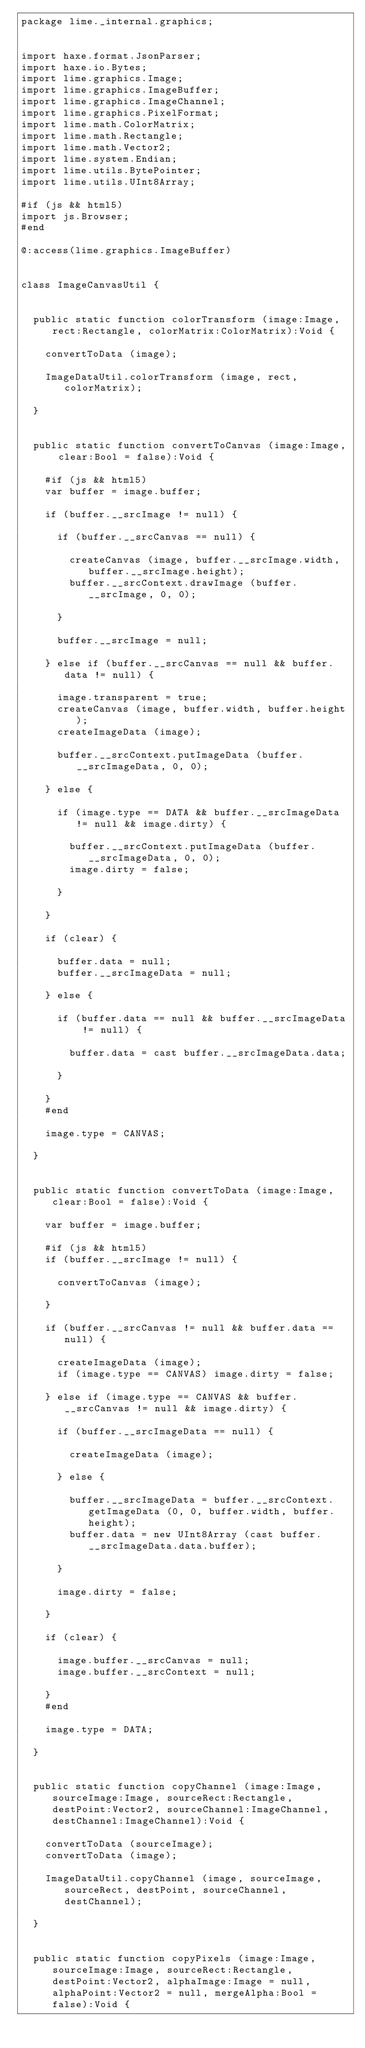Convert code to text. <code><loc_0><loc_0><loc_500><loc_500><_Haxe_>package lime._internal.graphics;


import haxe.format.JsonParser;
import haxe.io.Bytes;
import lime.graphics.Image;
import lime.graphics.ImageBuffer;
import lime.graphics.ImageChannel;
import lime.graphics.PixelFormat;
import lime.math.ColorMatrix;
import lime.math.Rectangle;
import lime.math.Vector2;
import lime.system.Endian;
import lime.utils.BytePointer;
import lime.utils.UInt8Array;

#if (js && html5)
import js.Browser;
#end

@:access(lime.graphics.ImageBuffer)


class ImageCanvasUtil {


	public static function colorTransform (image:Image, rect:Rectangle, colorMatrix:ColorMatrix):Void {

		convertToData (image);

		ImageDataUtil.colorTransform (image, rect, colorMatrix);

	}


	public static function convertToCanvas (image:Image, clear:Bool = false):Void {

		#if (js && html5)
		var buffer = image.buffer;

		if (buffer.__srcImage != null) {

			if (buffer.__srcCanvas == null) {

				createCanvas (image, buffer.__srcImage.width, buffer.__srcImage.height);
				buffer.__srcContext.drawImage (buffer.__srcImage, 0, 0);

			}

			buffer.__srcImage = null;

		} else if (buffer.__srcCanvas == null && buffer.data != null) {

			image.transparent = true;
			createCanvas (image, buffer.width, buffer.height);
			createImageData (image);

			buffer.__srcContext.putImageData (buffer.__srcImageData, 0, 0);

		} else {

			if (image.type == DATA && buffer.__srcImageData != null && image.dirty) {

				buffer.__srcContext.putImageData (buffer.__srcImageData, 0, 0);
				image.dirty = false;

			}

		}

		if (clear) {

			buffer.data = null;
			buffer.__srcImageData = null;

		} else {

			if (buffer.data == null && buffer.__srcImageData != null) {

				buffer.data = cast buffer.__srcImageData.data;

			}

		}
		#end

		image.type = CANVAS;

	}


	public static function convertToData (image:Image, clear:Bool = false):Void {

		var buffer = image.buffer;

		#if (js && html5)
		if (buffer.__srcImage != null) {

			convertToCanvas (image);

		}

		if (buffer.__srcCanvas != null && buffer.data == null) {

			createImageData (image);
			if (image.type == CANVAS) image.dirty = false;

		} else if (image.type == CANVAS && buffer.__srcCanvas != null && image.dirty) {

			if (buffer.__srcImageData == null) {

				createImageData (image);

			} else {

				buffer.__srcImageData = buffer.__srcContext.getImageData (0, 0, buffer.width, buffer.height);
				buffer.data = new UInt8Array (cast buffer.__srcImageData.data.buffer);

			}

			image.dirty = false;

		}

		if (clear) {

			image.buffer.__srcCanvas = null;
			image.buffer.__srcContext = null;

		}
		#end

		image.type = DATA;

	}


	public static function copyChannel (image:Image, sourceImage:Image, sourceRect:Rectangle, destPoint:Vector2, sourceChannel:ImageChannel, destChannel:ImageChannel):Void {

		convertToData (sourceImage);
		convertToData (image);

		ImageDataUtil.copyChannel (image, sourceImage, sourceRect, destPoint, sourceChannel, destChannel);

	}


	public static function copyPixels (image:Image, sourceImage:Image, sourceRect:Rectangle, destPoint:Vector2, alphaImage:Image = null, alphaPoint:Vector2 = null, mergeAlpha:Bool = false):Void {
</code> 